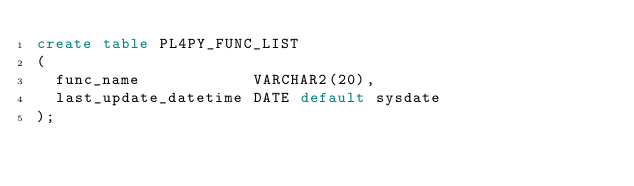Convert code to text. <code><loc_0><loc_0><loc_500><loc_500><_SQL_>create table PL4PY_FUNC_LIST
(
  func_name            VARCHAR2(20),
  last_update_datetime DATE default sysdate
);
</code> 